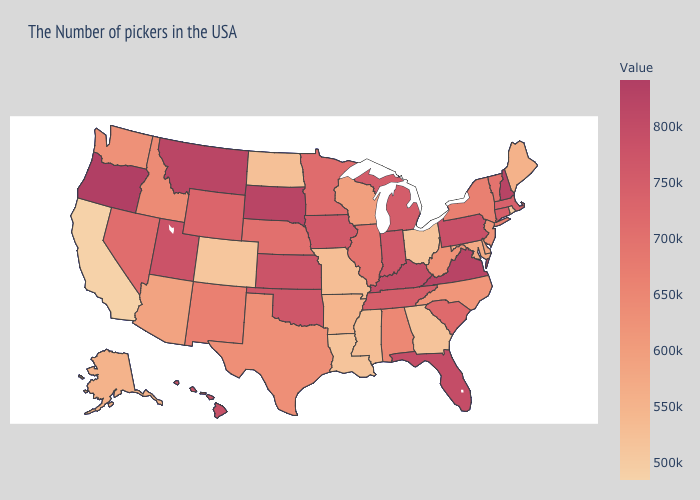Does Arkansas have the lowest value in the South?
Answer briefly. No. Which states hav the highest value in the West?
Be succinct. Oregon. Is the legend a continuous bar?
Short answer required. Yes. Does California have the lowest value in the USA?
Keep it brief. Yes. Is the legend a continuous bar?
Be succinct. Yes. Which states hav the highest value in the MidWest?
Answer briefly. South Dakota. 